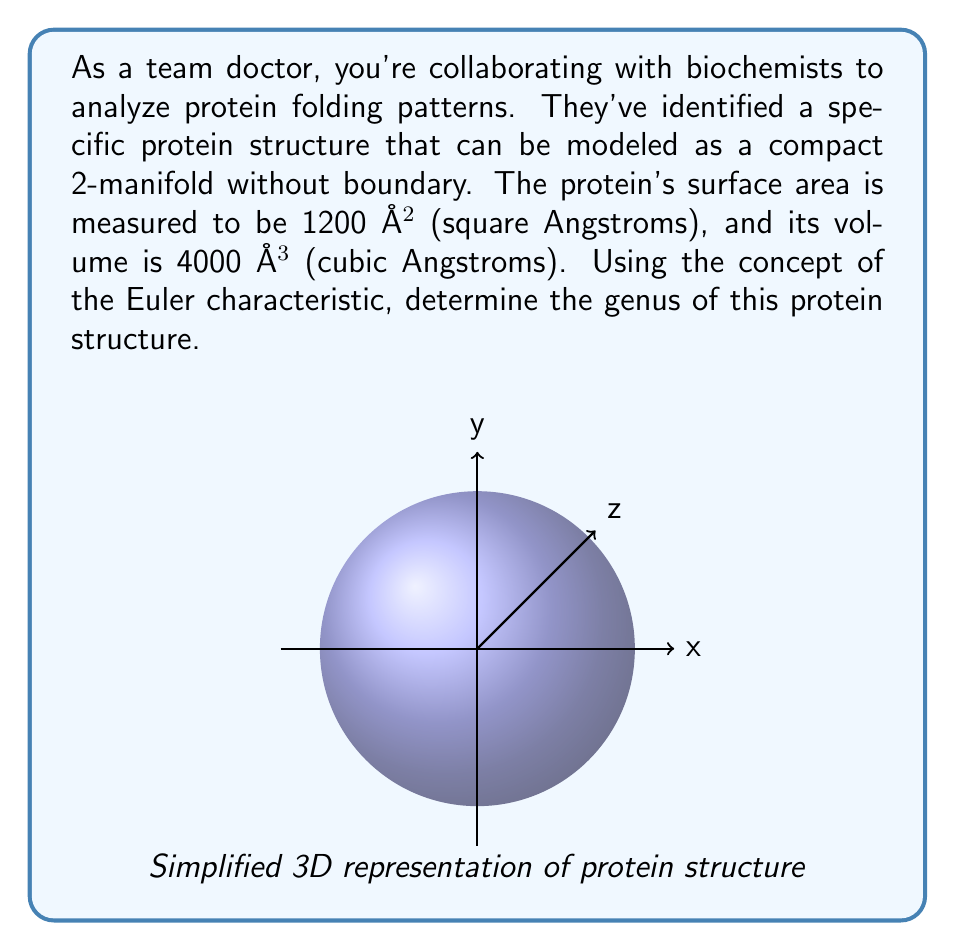Solve this math problem. To solve this problem, we'll use the following steps:

1) First, recall the Gauss-Bonnet theorem for a compact 2-manifold without boundary:

   $$\int_M K dA = 2\pi\chi(M)$$

   where $K$ is the Gaussian curvature, $dA$ is the area element, and $\chi(M)$ is the Euler characteristic.

2) For a sphere-like object, we can use the relation:

   $$\int_M K dA = \frac{4\pi A}{V}$$

   where $A$ is the surface area and $V$ is the volume.

3) Substituting the given values:

   $$\frac{4\pi(1200)}{4000} = 2\pi\chi(M)$$

4) Simplifying:

   $$3\pi = 2\pi\chi(M)$$
   $$\chi(M) = \frac{3}{2}$$

5) Now, recall the relation between Euler characteristic and genus for a closed surface:

   $$\chi(M) = 2 - 2g$$

   where $g$ is the genus.

6) Substituting our calculated Euler characteristic:

   $$\frac{3}{2} = 2 - 2g$$

7) Solving for $g$:

   $$2g = 2 - \frac{3}{2} = \frac{1}{4}$$
   $$g = \frac{1}{8}$$

Therefore, the genus of the protein structure is 1/8.
Answer: $\frac{1}{8}$ 